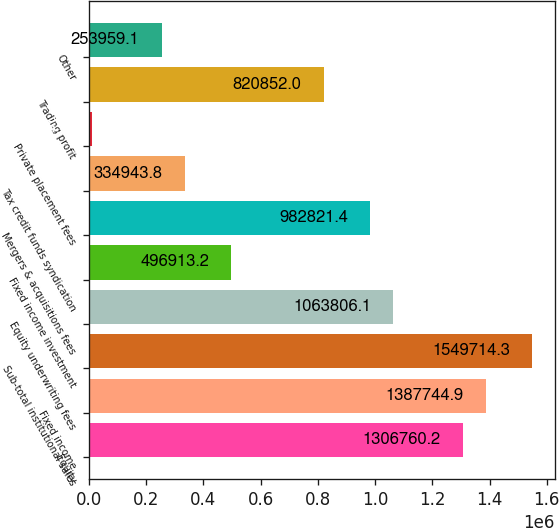Convert chart. <chart><loc_0><loc_0><loc_500><loc_500><bar_chart><fcel>Equity<fcel>Fixed income<fcel>Sub-total institutional sales<fcel>Equity underwriting fees<fcel>Fixed income investment<fcel>Mergers & acquisitions fees<fcel>Tax credit funds syndication<fcel>Private placement fees<fcel>Trading profit<fcel>Other<nl><fcel>1.30676e+06<fcel>1.38774e+06<fcel>1.54971e+06<fcel>1.06381e+06<fcel>496913<fcel>982821<fcel>334944<fcel>11005<fcel>820852<fcel>253959<nl></chart> 